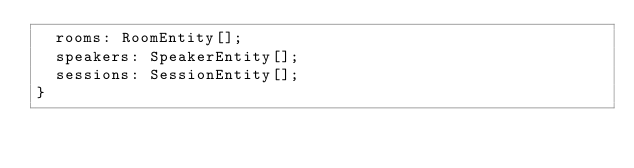<code> <loc_0><loc_0><loc_500><loc_500><_TypeScript_>  rooms: RoomEntity[];
  speakers: SpeakerEntity[];
  sessions: SessionEntity[];
}
</code> 